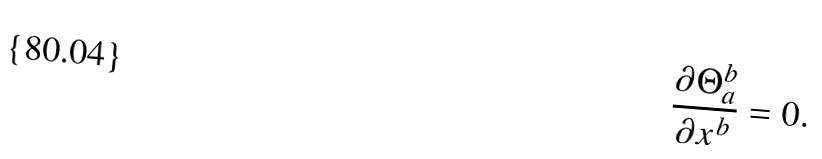<formula> <loc_0><loc_0><loc_500><loc_500>\frac { \partial \Theta ^ { b } _ { a } } { \partial x ^ { b } } = 0 .</formula> 